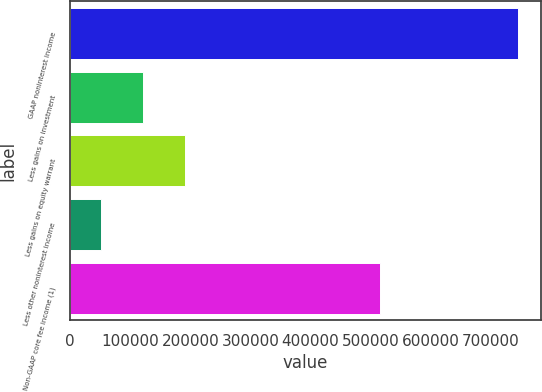<chart> <loc_0><loc_0><loc_500><loc_500><bar_chart><fcel>GAAP noninterest income<fcel>Less gains on investment<fcel>Less gains on equity warrant<fcel>Less other noninterest income<fcel>Non-GAAP core fee income (1)<nl><fcel>744984<fcel>121171<fcel>190483<fcel>51858<fcel>515890<nl></chart> 